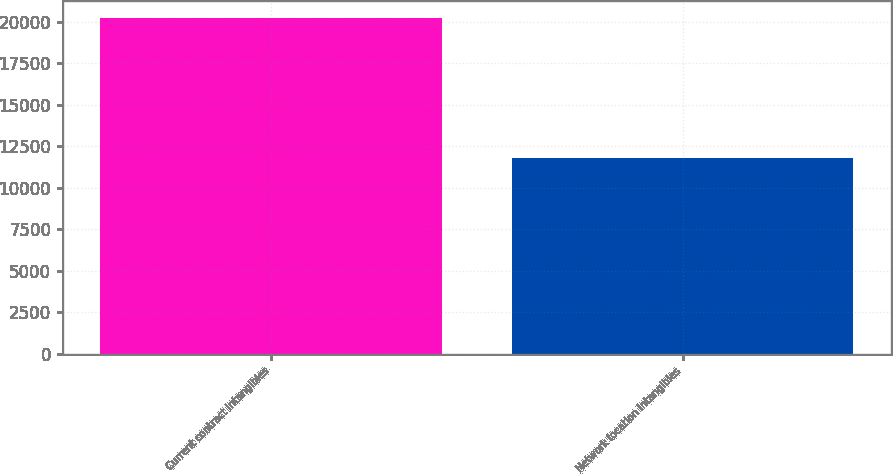<chart> <loc_0><loc_0><loc_500><loc_500><bar_chart><fcel>Current contract intangibles<fcel>Network location intangibles<nl><fcel>20210<fcel>11805<nl></chart> 